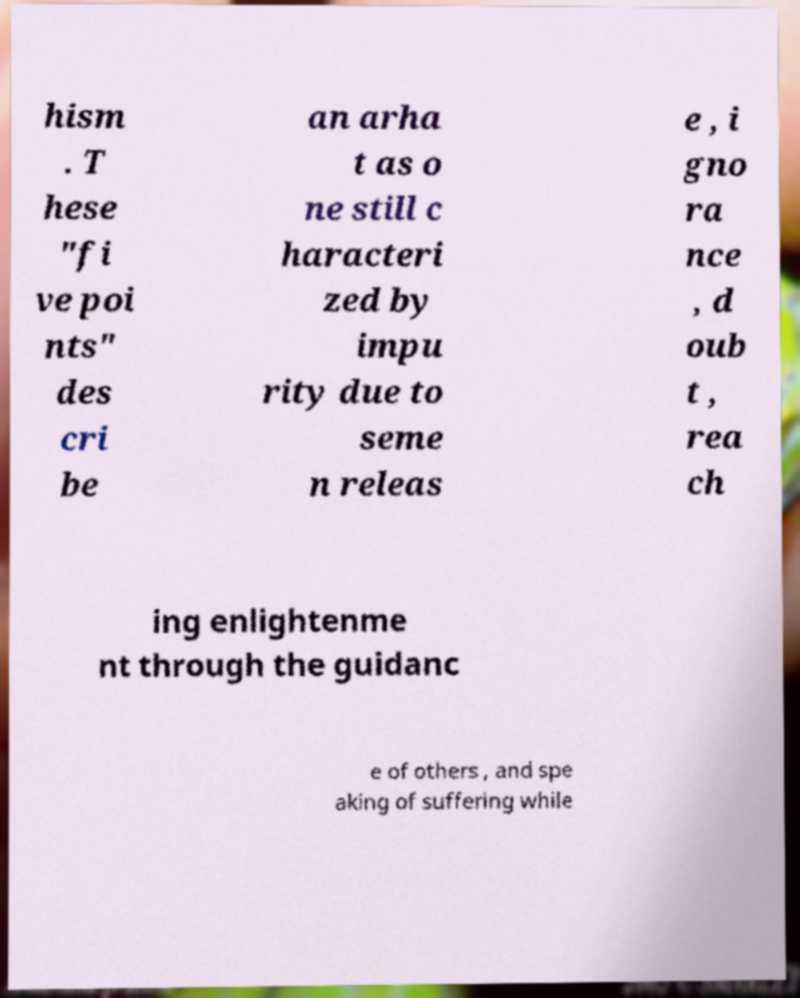Please identify and transcribe the text found in this image. hism . T hese "fi ve poi nts" des cri be an arha t as o ne still c haracteri zed by impu rity due to seme n releas e , i gno ra nce , d oub t , rea ch ing enlightenme nt through the guidanc e of others , and spe aking of suffering while 